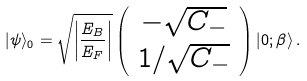Convert formula to latex. <formula><loc_0><loc_0><loc_500><loc_500>| \psi \rangle _ { 0 } = \sqrt { \left | \frac { E _ { B } } { E _ { F } } \right | } \left ( \begin{array} { c } - \sqrt { C _ { - } } \\ 1 / \sqrt { C _ { - } } \end{array} \right ) | 0 ; \beta \rangle \, .</formula> 